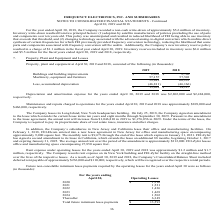From Frequency Electronics's financial document, What is the amount of maintenance and repairs charged to operations for 2019 and 2018 respectively? The document shows two values: $309,000 and $466,000. From the document: "l 30, 2019 and 2018 was approximately $309,000 and $466,000, respectively. The Company leases its Long Island, New York headquarters building. On July..." Also, What is the depreciation and amortization expense for 2019 and 2018 respectively? The document shows two values: $2,802,000 and $2,484,000. From the document: "s ended April 30, 2019 and 2018 was $2,802,000 and $2,484,000, respectively. Maintenance and repairs charged to operations for the years ended April 3..." Also, What is the amount of buildings and building improvements in 2019 and 2018 respectively? The document shows two values: $2,692 and $2,790 (in thousands). From the document: "018 Buildings and building improvements $ 2,692 $ 2,790 : 2019 2018 Buildings and building improvements $ 2,692 $ 2,790..." Also, can you calculate: What is the average value of buildings and building improvements in 2018 and 2019? To answer this question, I need to perform calculations using the financial data. The calculation is: (2,692+2,790)/2, which equals 2741 (in thousands). This is based on the information: ": 2019 2018 Buildings and building improvements $ 2,692 $ 2,790 018 Buildings and building improvements $ 2,692 $ 2,790..." The key data points involved are: 2,692, 2,790. Also, can you calculate: What is the change between the value of machinery, equipment and furniture between 2018 and 2019? Based on the calculation: 57,157-57,503, the result is -346 (in thousands). This is based on the information: "Machinery, equipment and furniture 57,157 57,503 59,849 60,293 Machinery, equipment and furniture 57,157 57,503 59,849 60,293..." The key data points involved are: 57,157, 57,503. Also, can you calculate: What is the total maintenance and repairs charged to operations for 2018 and 2019? Based on the calculation: 309,000+466,000, the result is 775000. This is based on the information: "ended April 30, 2019 and 2018 was approximately $309,000 and $466,000, respectively. The Company leases its Long Island, New York headquarters building. On 30, 2019 and 2018 was approximately $309,000..." The key data points involved are: 309,000, 466,000. 